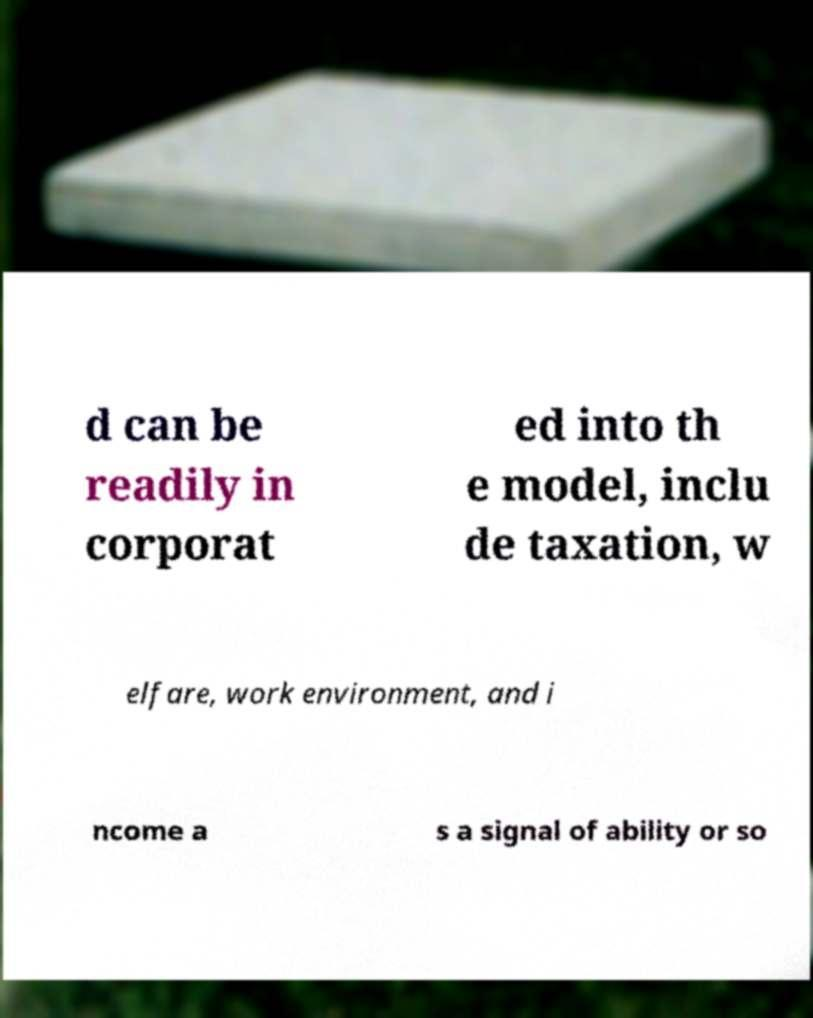Could you extract and type out the text from this image? d can be readily in corporat ed into th e model, inclu de taxation, w elfare, work environment, and i ncome a s a signal of ability or so 